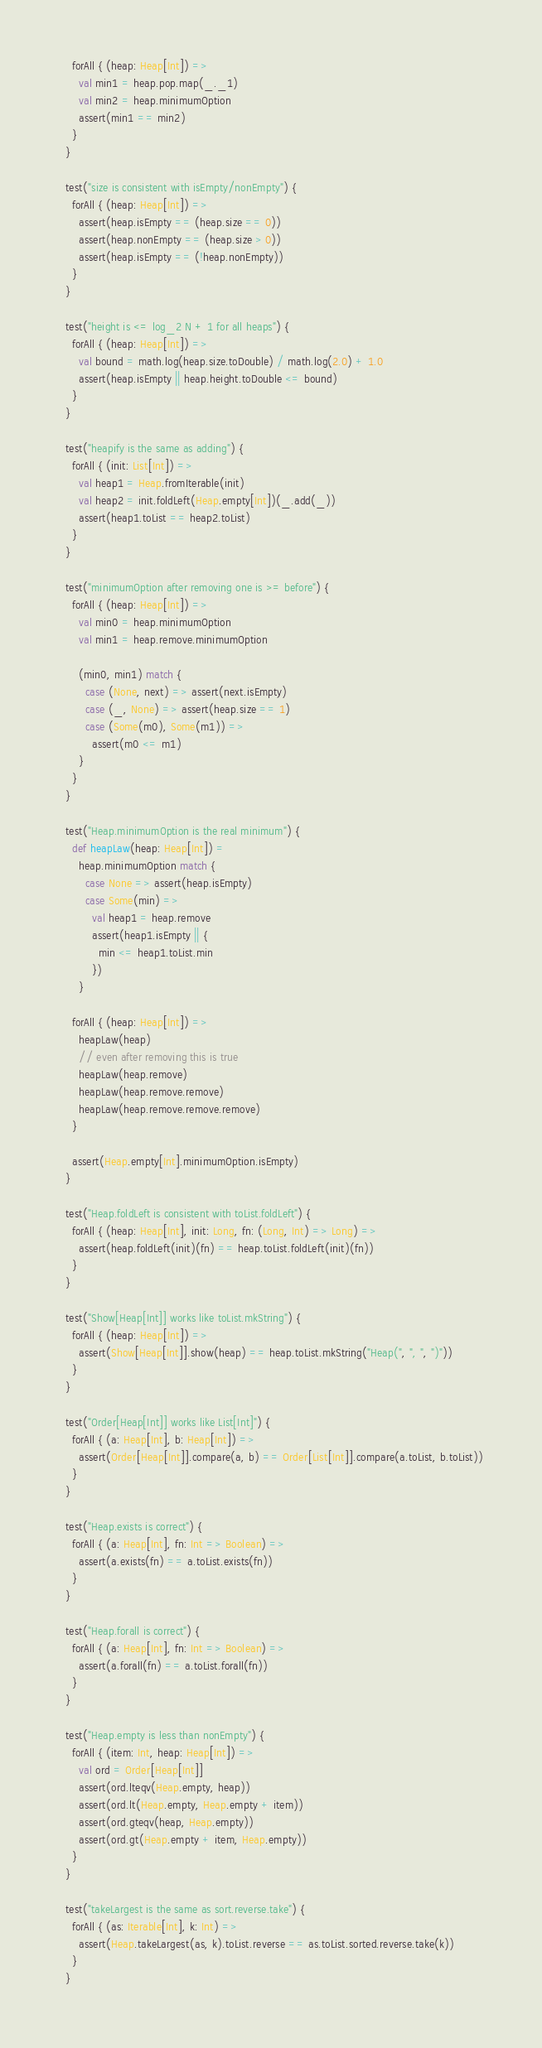Convert code to text. <code><loc_0><loc_0><loc_500><loc_500><_Scala_>    forAll { (heap: Heap[Int]) =>
      val min1 = heap.pop.map(_._1)
      val min2 = heap.minimumOption
      assert(min1 == min2)
    }
  }

  test("size is consistent with isEmpty/nonEmpty") {
    forAll { (heap: Heap[Int]) =>
      assert(heap.isEmpty == (heap.size == 0))
      assert(heap.nonEmpty == (heap.size > 0))
      assert(heap.isEmpty == (!heap.nonEmpty))
    }
  }

  test("height is <= log_2 N + 1 for all heaps") {
    forAll { (heap: Heap[Int]) =>
      val bound = math.log(heap.size.toDouble) / math.log(2.0) + 1.0
      assert(heap.isEmpty || heap.height.toDouble <= bound)
    }
  }

  test("heapify is the same as adding") {
    forAll { (init: List[Int]) =>
      val heap1 = Heap.fromIterable(init)
      val heap2 = init.foldLeft(Heap.empty[Int])(_.add(_))
      assert(heap1.toList == heap2.toList)
    }
  }

  test("minimumOption after removing one is >= before") {
    forAll { (heap: Heap[Int]) =>
      val min0 = heap.minimumOption
      val min1 = heap.remove.minimumOption

      (min0, min1) match {
        case (None, next) => assert(next.isEmpty)
        case (_, None) => assert(heap.size == 1)
        case (Some(m0), Some(m1)) =>
          assert(m0 <= m1)
      }
    }
  }

  test("Heap.minimumOption is the real minimum") {
    def heapLaw(heap: Heap[Int]) =
      heap.minimumOption match {
        case None => assert(heap.isEmpty)
        case Some(min) =>
          val heap1 = heap.remove
          assert(heap1.isEmpty || {
            min <= heap1.toList.min
          })
      }

    forAll { (heap: Heap[Int]) =>
      heapLaw(heap)
      // even after removing this is true
      heapLaw(heap.remove)
      heapLaw(heap.remove.remove)
      heapLaw(heap.remove.remove.remove)
    }

    assert(Heap.empty[Int].minimumOption.isEmpty)
  }

  test("Heap.foldLeft is consistent with toList.foldLeft") {
    forAll { (heap: Heap[Int], init: Long, fn: (Long, Int) => Long) =>
      assert(heap.foldLeft(init)(fn) == heap.toList.foldLeft(init)(fn))
    }
  }

  test("Show[Heap[Int]] works like toList.mkString") {
    forAll { (heap: Heap[Int]) =>
      assert(Show[Heap[Int]].show(heap) == heap.toList.mkString("Heap(", ", ", ")"))
    }
  }

  test("Order[Heap[Int]] works like List[Int]") {
    forAll { (a: Heap[Int], b: Heap[Int]) =>
      assert(Order[Heap[Int]].compare(a, b) == Order[List[Int]].compare(a.toList, b.toList))
    }
  }

  test("Heap.exists is correct") {
    forAll { (a: Heap[Int], fn: Int => Boolean) =>
      assert(a.exists(fn) == a.toList.exists(fn))
    }
  }

  test("Heap.forall is correct") {
    forAll { (a: Heap[Int], fn: Int => Boolean) =>
      assert(a.forall(fn) == a.toList.forall(fn))
    }
  }

  test("Heap.empty is less than nonEmpty") {
    forAll { (item: Int, heap: Heap[Int]) =>
      val ord = Order[Heap[Int]]
      assert(ord.lteqv(Heap.empty, heap))
      assert(ord.lt(Heap.empty, Heap.empty + item))
      assert(ord.gteqv(heap, Heap.empty))
      assert(ord.gt(Heap.empty + item, Heap.empty))
    }
  }

  test("takeLargest is the same as sort.reverse.take") {
    forAll { (as: Iterable[Int], k: Int) =>
      assert(Heap.takeLargest(as, k).toList.reverse == as.toList.sorted.reverse.take(k))
    }
  }
</code> 